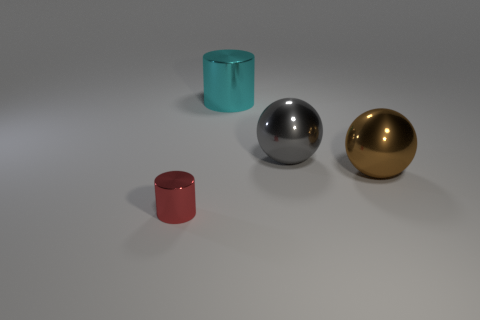Are there any big brown things on the left side of the large gray object?
Offer a terse response. No. There is another large metallic object that is the same shape as the brown thing; what color is it?
Your response must be concise. Gray. Are there any other things that have the same shape as the gray shiny thing?
Your response must be concise. Yes. What is the sphere to the right of the gray metallic object made of?
Give a very brief answer. Metal. There is another object that is the same shape as the big brown object; what is its size?
Your response must be concise. Large. What number of large gray cubes are made of the same material as the big brown ball?
Your answer should be very brief. 0. What number of things are big things that are on the left side of the large gray shiny sphere or shiny balls in front of the gray object?
Offer a very short reply. 2. Is the number of brown balls in front of the tiny object less than the number of large brown metallic objects?
Your answer should be very brief. Yes. Are there any metallic cylinders that have the same size as the gray ball?
Offer a terse response. Yes. The large metallic cylinder is what color?
Offer a very short reply. Cyan. 